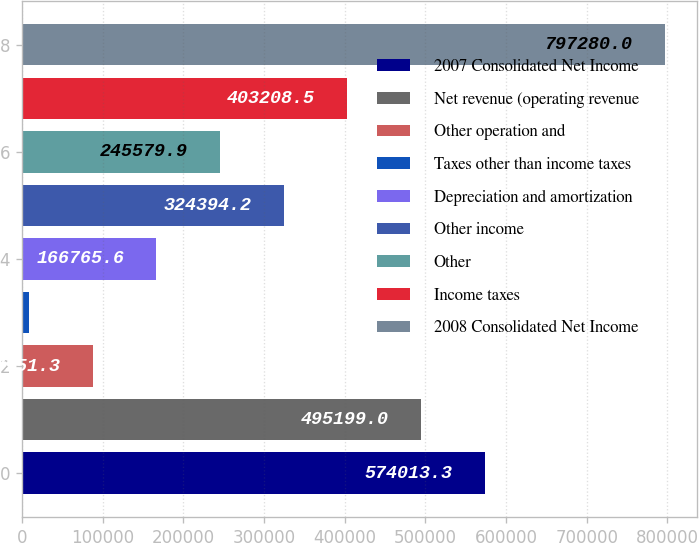<chart> <loc_0><loc_0><loc_500><loc_500><bar_chart><fcel>2007 Consolidated Net Income<fcel>Net revenue (operating revenue<fcel>Other operation and<fcel>Taxes other than income taxes<fcel>Depreciation and amortization<fcel>Other income<fcel>Other<fcel>Income taxes<fcel>2008 Consolidated Net Income<nl><fcel>574013<fcel>495199<fcel>87951.3<fcel>9137<fcel>166766<fcel>324394<fcel>245580<fcel>403208<fcel>797280<nl></chart> 